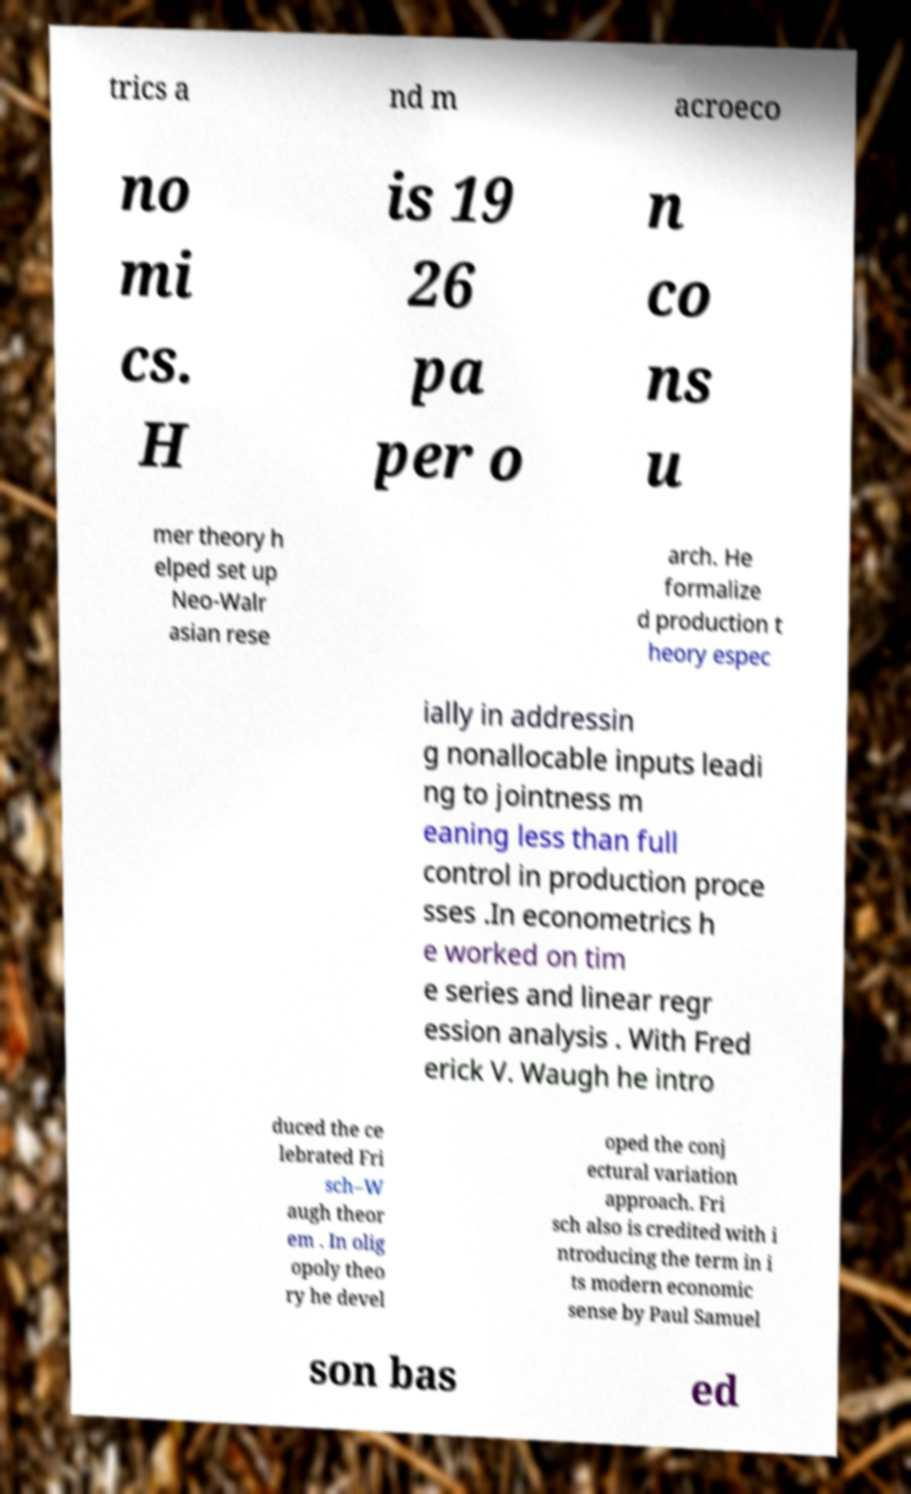Can you read and provide the text displayed in the image?This photo seems to have some interesting text. Can you extract and type it out for me? trics a nd m acroeco no mi cs. H is 19 26 pa per o n co ns u mer theory h elped set up Neo-Walr asian rese arch. He formalize d production t heory espec ially in addressin g nonallocable inputs leadi ng to jointness m eaning less than full control in production proce sses .In econometrics h e worked on tim e series and linear regr ession analysis . With Fred erick V. Waugh he intro duced the ce lebrated Fri sch–W augh theor em . In olig opoly theo ry he devel oped the conj ectural variation approach. Fri sch also is credited with i ntroducing the term in i ts modern economic sense by Paul Samuel son bas ed 